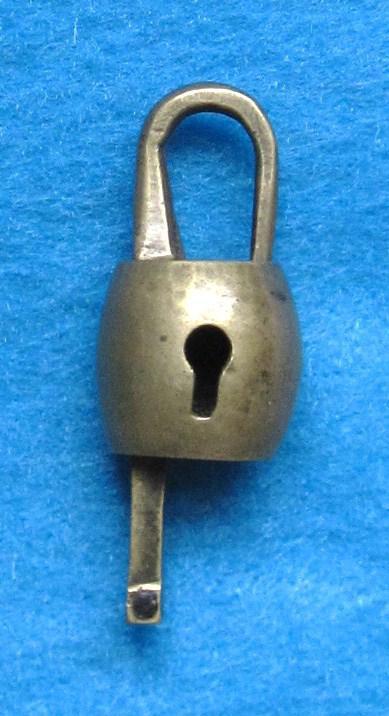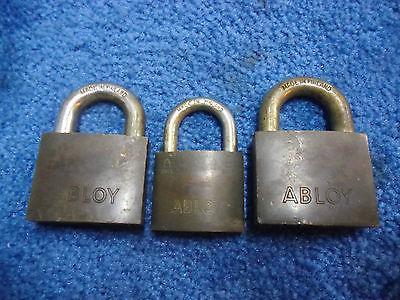The first image is the image on the left, the second image is the image on the right. Considering the images on both sides, is "A key is alongside a lock, and no keys are inserted in a lock, in one image." valid? Answer yes or no. No. The first image is the image on the left, the second image is the image on the right. For the images shown, is this caption "There are at least two locks with their keys shown in one of the images." true? Answer yes or no. No. The first image is the image on the left, the second image is the image on the right. Assess this claim about the two images: "There is at least 1 lock with a chain in the right image.". Correct or not? Answer yes or no. No. 